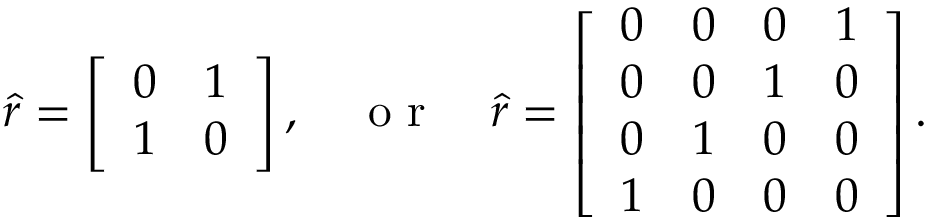<formula> <loc_0><loc_0><loc_500><loc_500>\hat { r } = \left [ \begin{array} { c c } { 0 } & { 1 } \\ { 1 } & { 0 } \end{array} \right ] , \quad o r \quad \hat { r } = \left [ \begin{array} { c c c c } { 0 } & { 0 } & { 0 } & { 1 } \\ { 0 } & { 0 } & { 1 } & { 0 } \\ { 0 } & { 1 } & { 0 } & { 0 } \\ { 1 } & { 0 } & { 0 } & { 0 } \end{array} \right ] .</formula> 